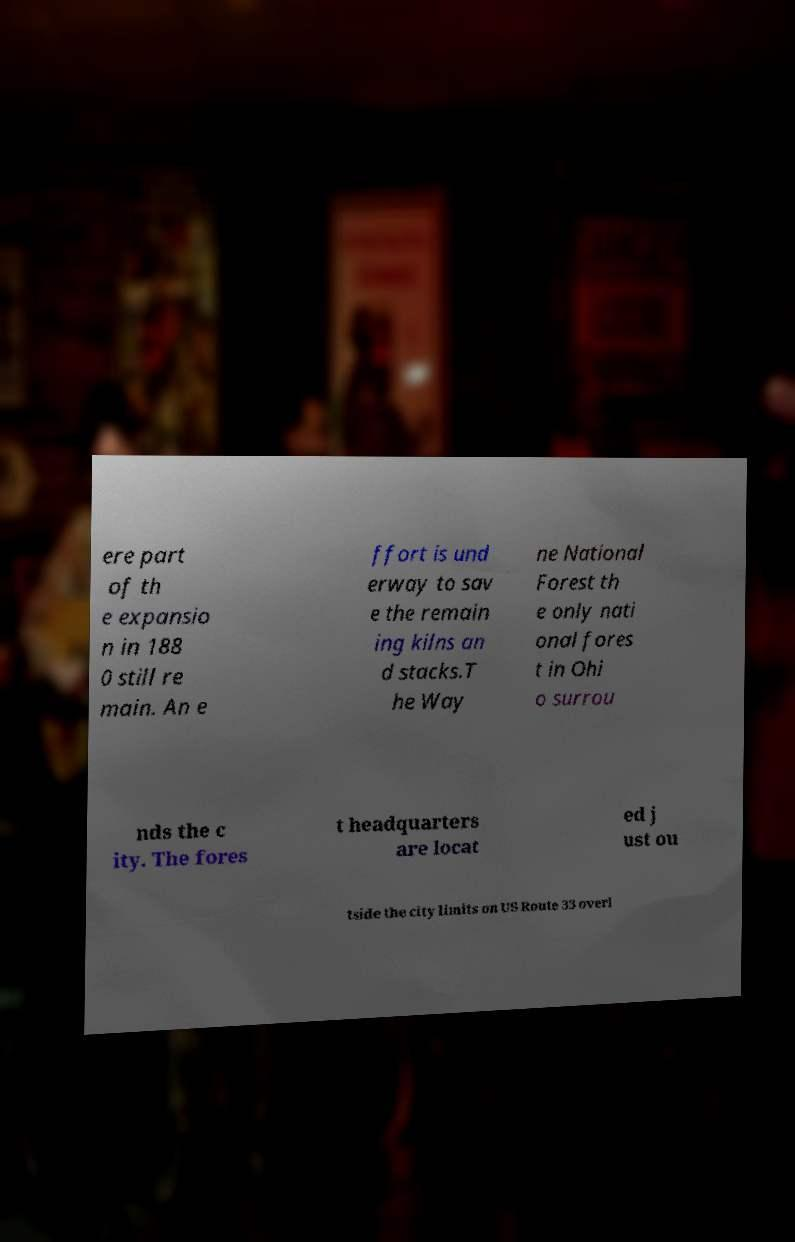Can you accurately transcribe the text from the provided image for me? ere part of th e expansio n in 188 0 still re main. An e ffort is und erway to sav e the remain ing kilns an d stacks.T he Way ne National Forest th e only nati onal fores t in Ohi o surrou nds the c ity. The fores t headquarters are locat ed j ust ou tside the city limits on US Route 33 overl 